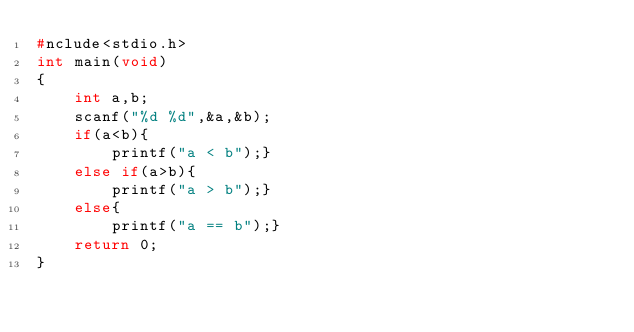<code> <loc_0><loc_0><loc_500><loc_500><_C_>#nclude<stdio.h>
int main(void)
{
    int a,b;
    scanf("%d %d",&a,&b);
    if(a<b){
        printf("a < b");}
    else if(a>b){
        printf("a > b");}
    else{
        printf("a == b");}
    return 0;
}</code> 